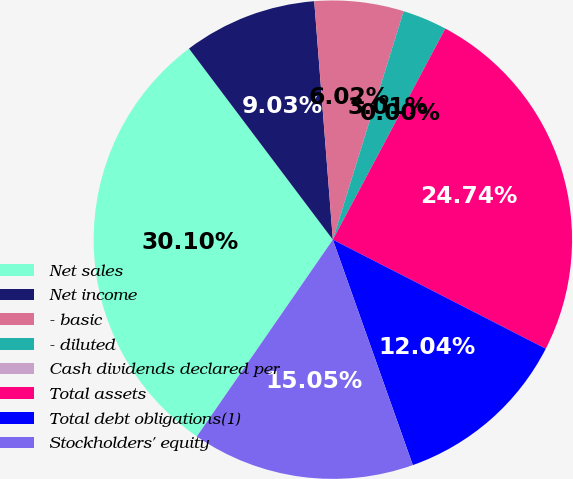<chart> <loc_0><loc_0><loc_500><loc_500><pie_chart><fcel>Net sales<fcel>Net income<fcel>- basic<fcel>- diluted<fcel>Cash dividends declared per<fcel>Total assets<fcel>Total debt obligations(1)<fcel>Stockholders' equity<nl><fcel>30.1%<fcel>9.03%<fcel>6.02%<fcel>3.01%<fcel>0.0%<fcel>24.74%<fcel>12.04%<fcel>15.05%<nl></chart> 